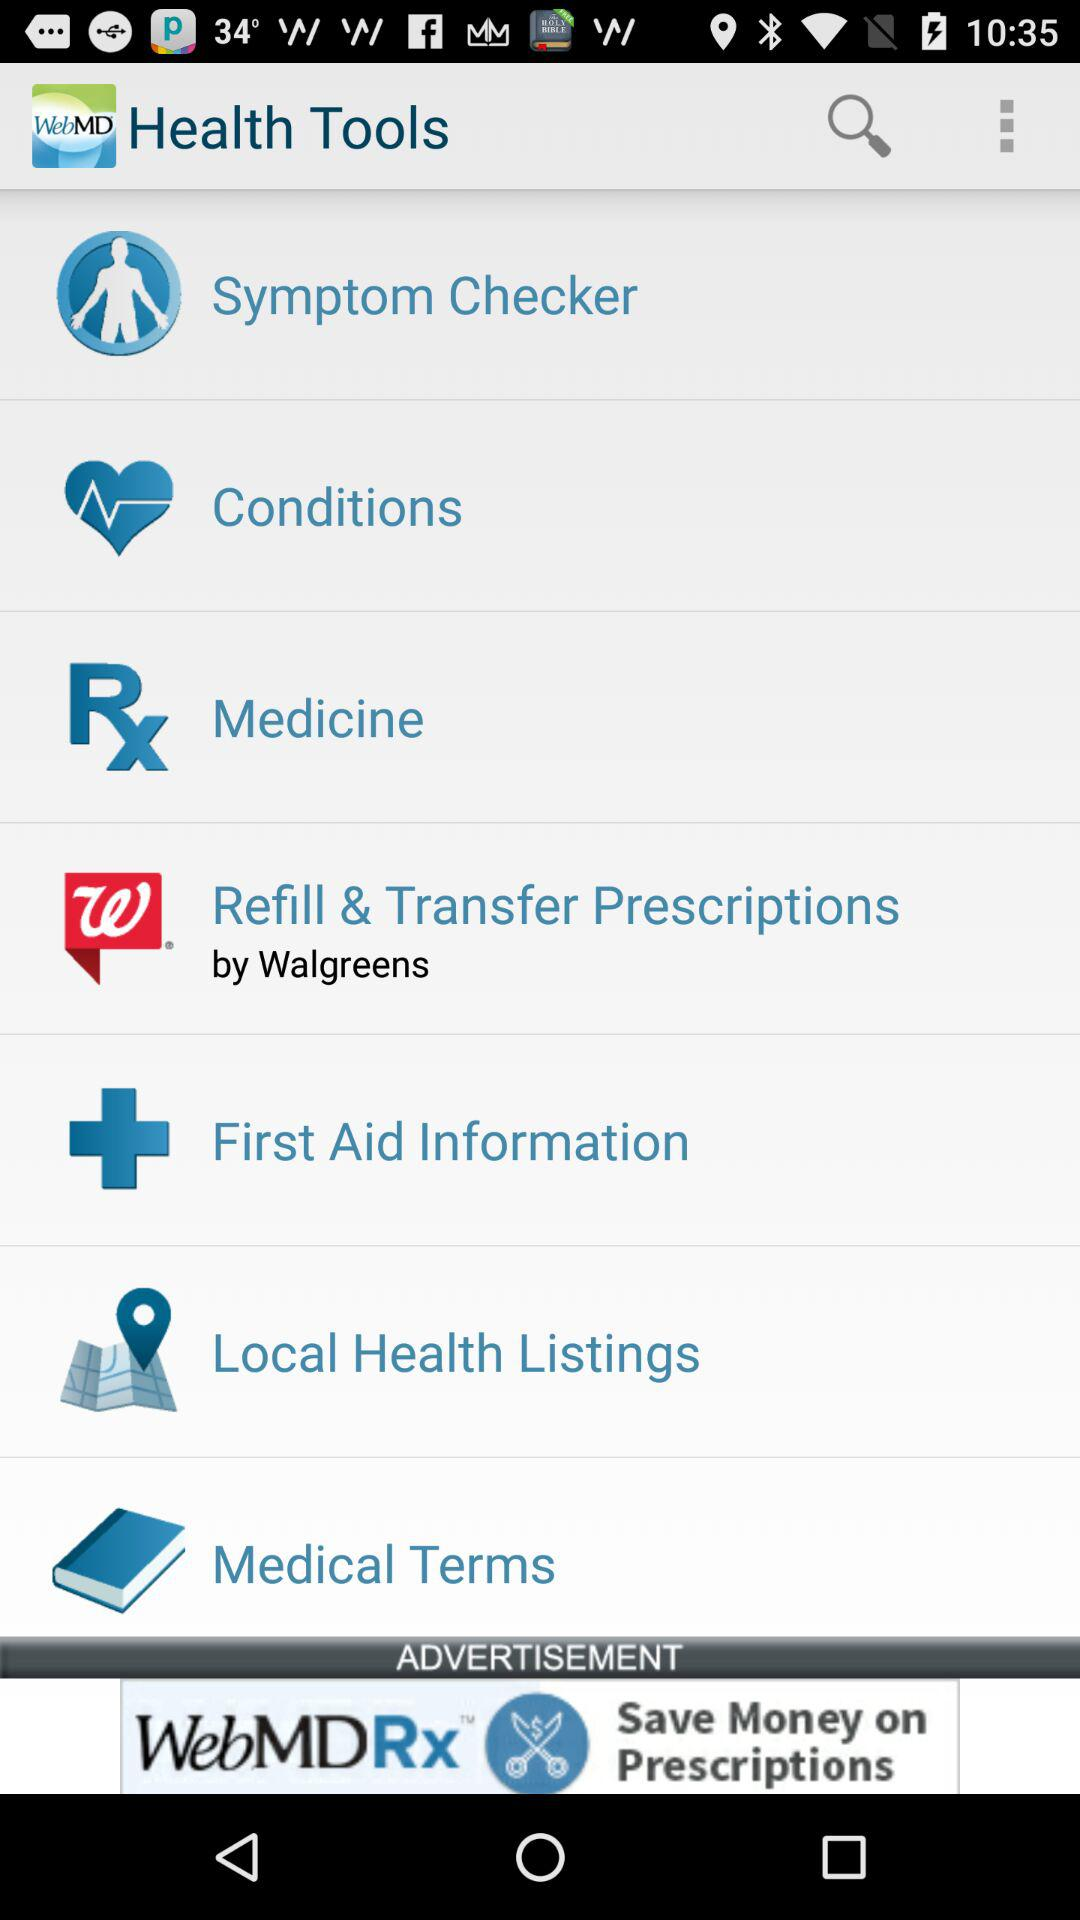What are the features available in "WebMD" application? The available features are "Symptom Checker", "Conditions", "Medicine", "Refill & Transfer Prescriptions", "First Aid Information", "Local Health Listings" and "Medical Terms". 